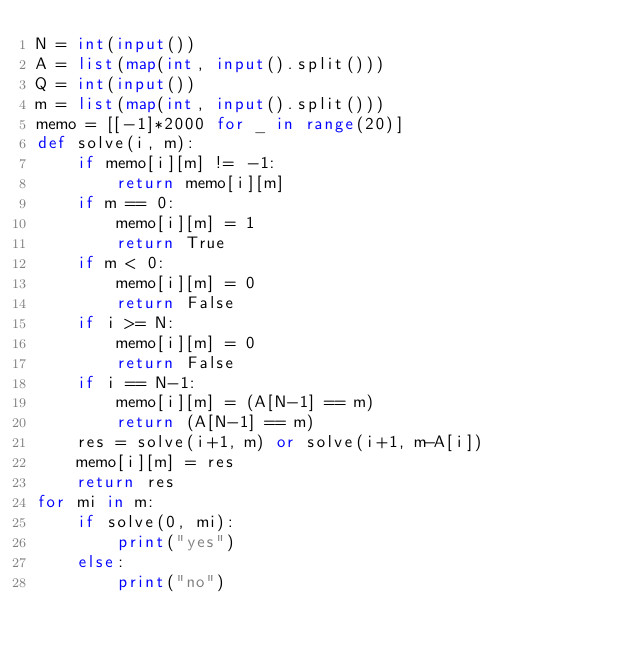Convert code to text. <code><loc_0><loc_0><loc_500><loc_500><_Python_>N = int(input())
A = list(map(int, input().split()))
Q = int(input())
m = list(map(int, input().split()))
memo = [[-1]*2000 for _ in range(20)]
def solve(i, m):
    if memo[i][m] != -1:
        return memo[i][m]
    if m == 0:
        memo[i][m] = 1
        return True
    if m < 0:
        memo[i][m] = 0
        return False
    if i >= N:
        memo[i][m] = 0
        return False
    if i == N-1:
        memo[i][m] = (A[N-1] == m)
        return (A[N-1] == m)
    res = solve(i+1, m) or solve(i+1, m-A[i])
    memo[i][m] = res
    return res
for mi in m:
    if solve(0, mi):
        print("yes")
    else:
        print("no")
</code> 